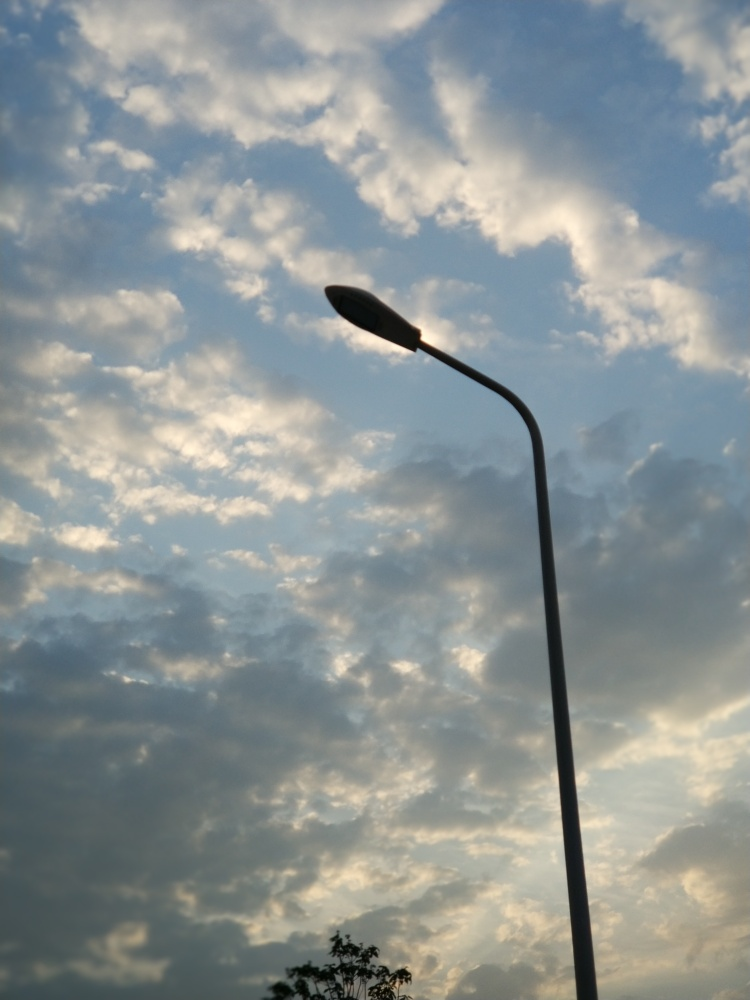How is the focus in this image?
A. unfocused
B. blurred
C. accurate
Answer with the option's letter from the given choices directly.
 C. 